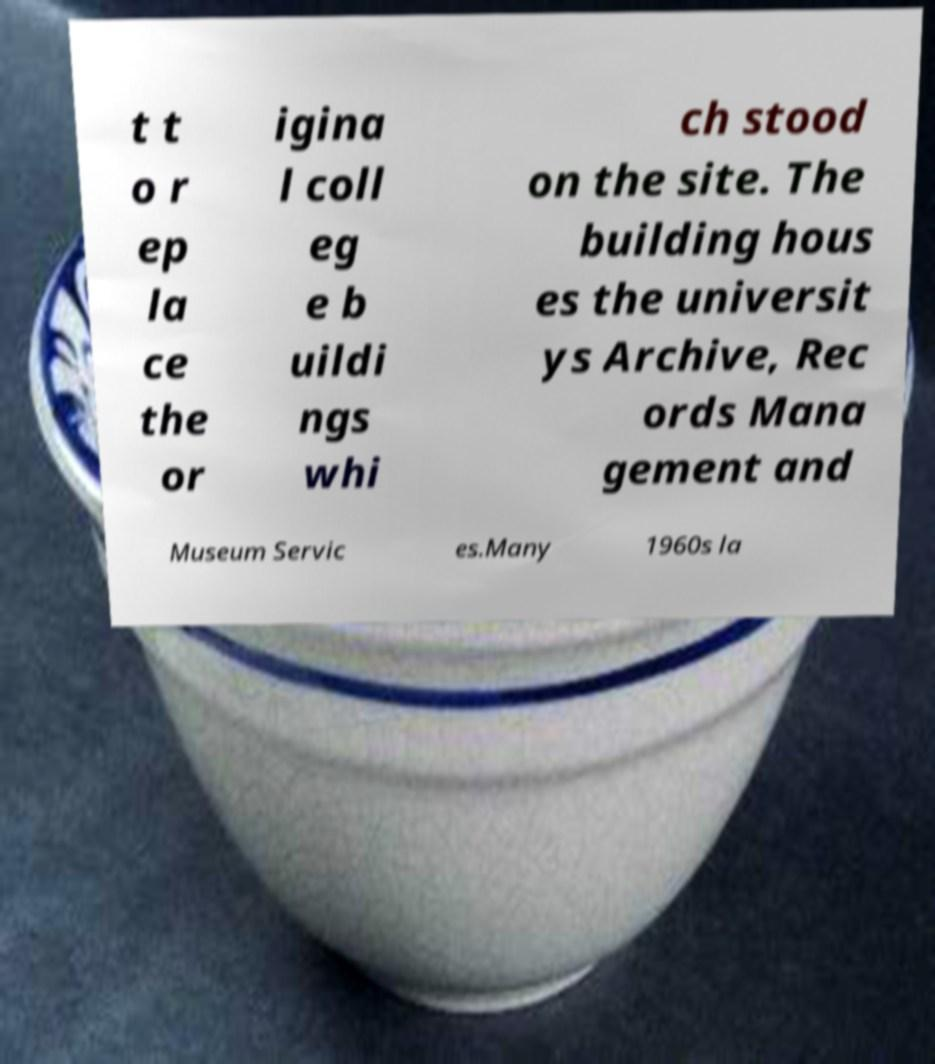Can you accurately transcribe the text from the provided image for me? t t o r ep la ce the or igina l coll eg e b uildi ngs whi ch stood on the site. The building hous es the universit ys Archive, Rec ords Mana gement and Museum Servic es.Many 1960s la 